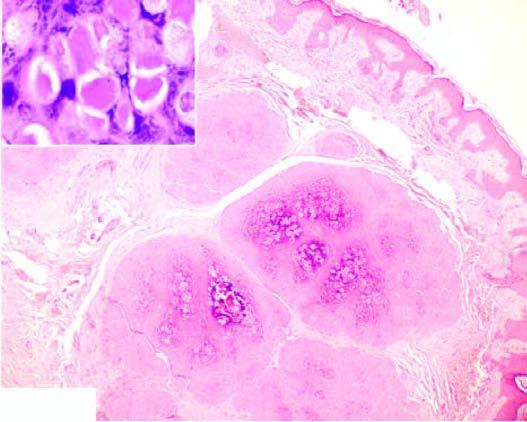what show numerous molluscum bodies which are intracytoplasmic inclusions?
Answer the question using a single word or phrase. Epidermal layers 